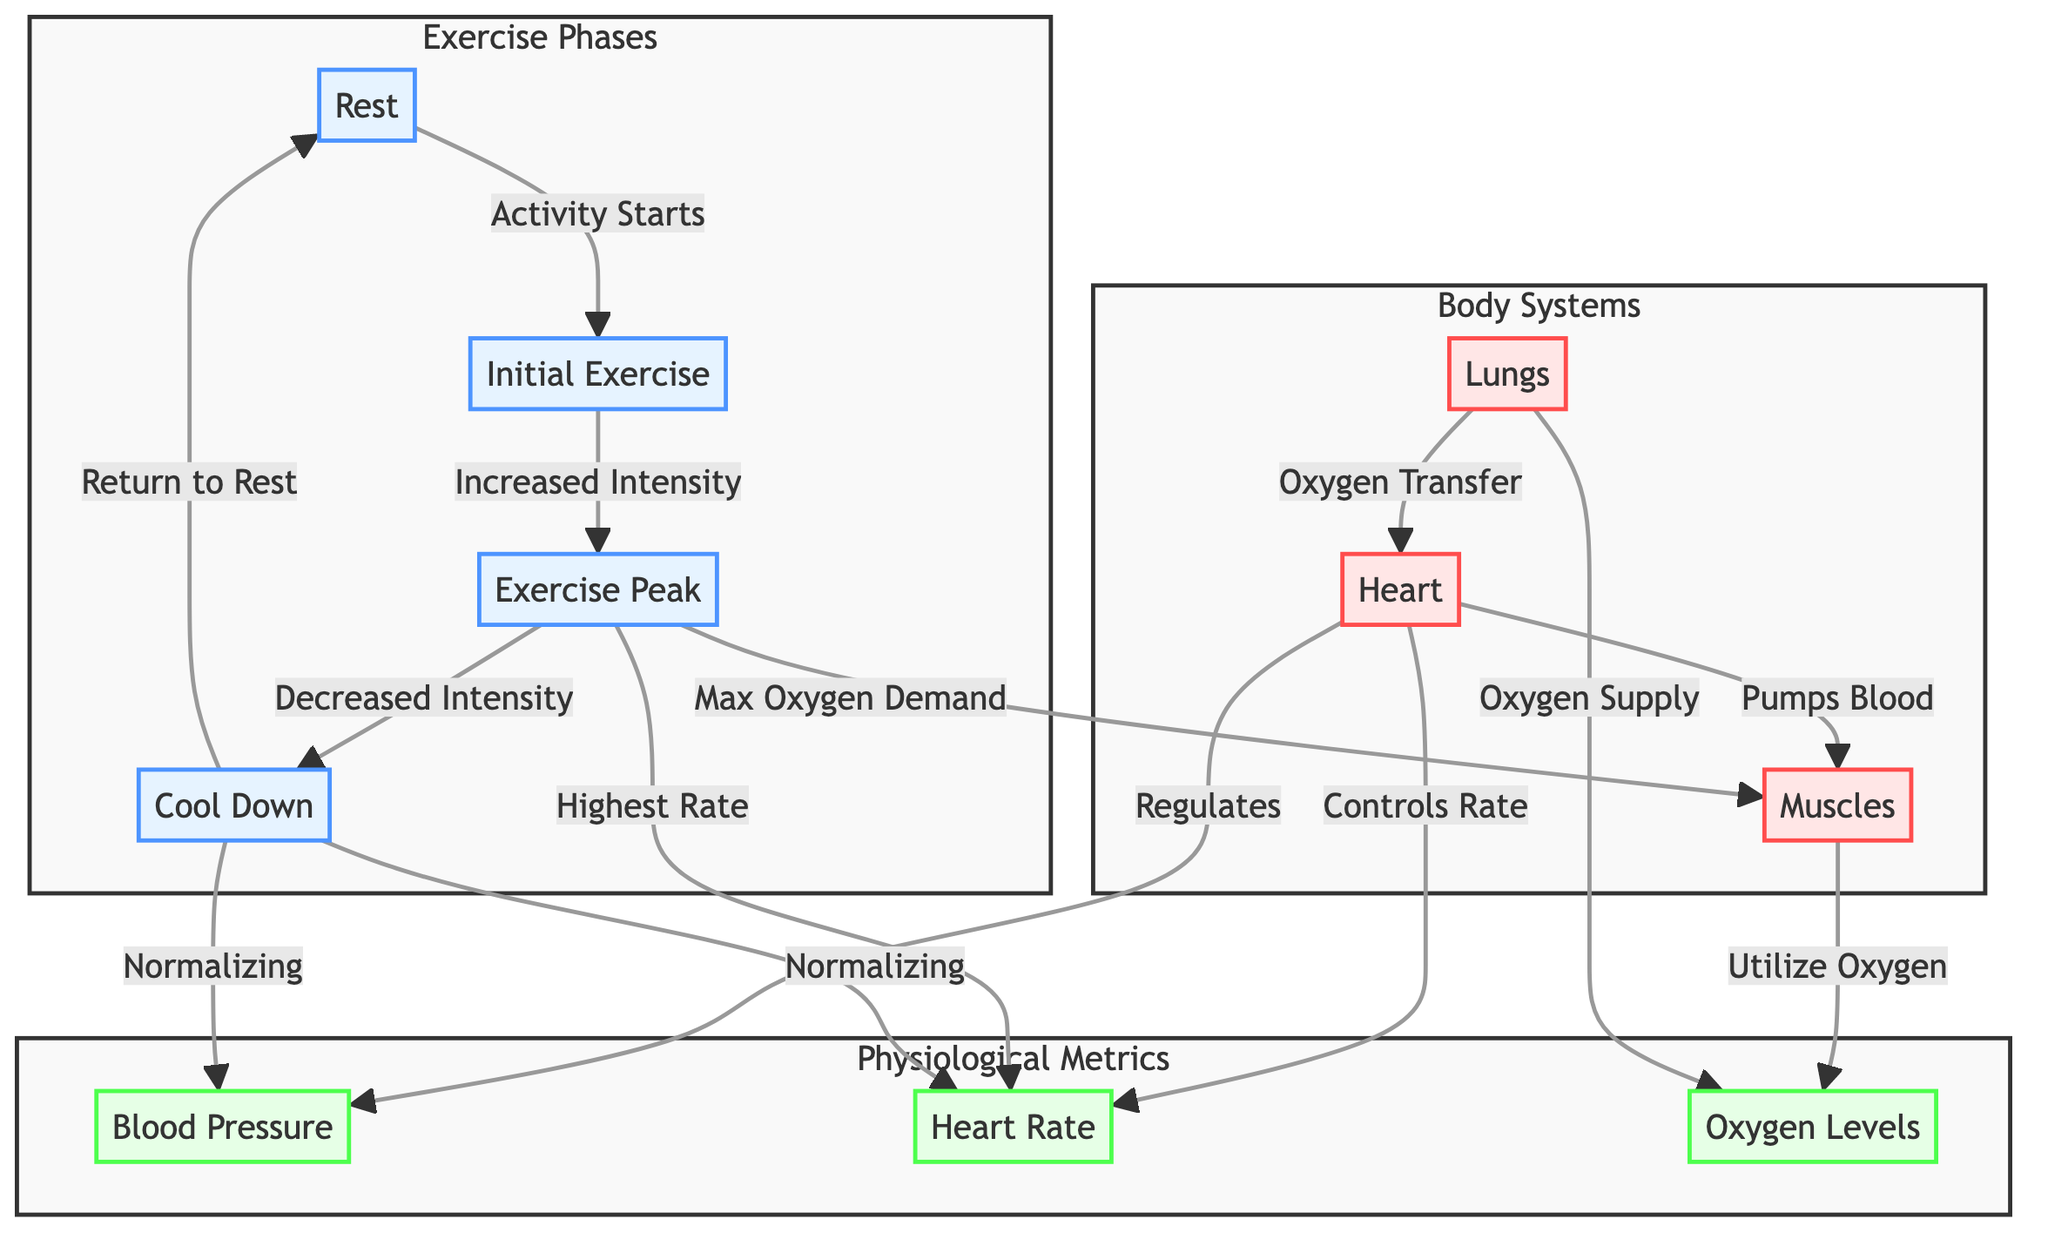What is the first phase of exercise? The diagram shows the phases of exercise starting from "Rest", and the first phase of exercise is "Initial Exercise".
Answer: Initial Exercise What organ is responsible for pumping blood to the muscles? In the diagram, the heart is indicated as the organ that pumps blood to the muscles, as shown by the label "Pumps Blood".
Answer: Heart During the "Exercise Peak," what is the relationship between heart rate and oxygen demand? The diagram shows that at the "Exercise Peak," there is a "Max Oxygen Demand" from the muscles accompanied by the "Highest Rate" of heart rate. This indicates a direct connection between increased activity and both metrics.
Answer: Direct connection What happens to blood pressure during the cool down? According to the diagram, the "Cool Down" phase is associated with "Normalizing" of blood pressure, meaning it returns to baseline levels.
Answer: Normalizing How many phases are displayed in the diagram? The diagram lists four distinct phases of physical activity: Rest, Initial Exercise, Exercise Peak, and Cool Down. By counting these, we find there are four phases.
Answer: Four What happens to the heart rate immediately after exercise peak? The diagram indicates that after the "Exercise Peak," the heart rate begins to normalize during the "Cool Down" phase. This suggests a decrease in heart rate as the body recovers.
Answer: Normalize What organ is involved in the oxygen supply to the muscles? The lungs are indicated in the diagram as being responsible for providing oxygen to the muscles, highlighted with the label "Oxygen Supply".
Answer: Lungs What physiological metric is linked with the control of heart rate? The diagram specifies that the "Heart" controls the "Heart Rate," showing a direct relationship between the organ and the physiological metric.
Answer: Heart Rate During what phase does the highest oxygen demand occur? The diagram explicitly states that the "Exercise Peak" phase is where the "Max Oxygen Demand" occurs in the muscles.
Answer: Exercise Peak 